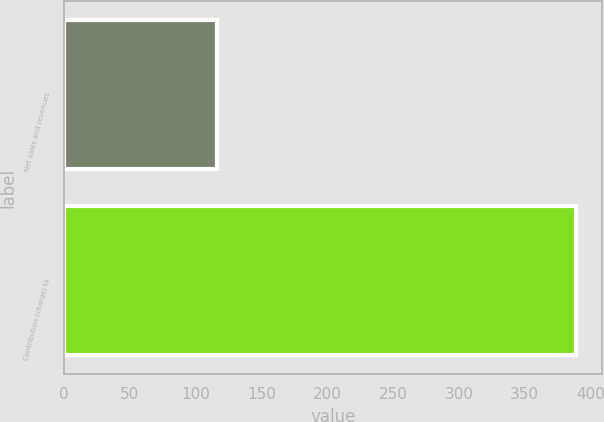Convert chart. <chart><loc_0><loc_0><loc_500><loc_500><bar_chart><fcel>Net sales and revenues<fcel>Contribution (charge) to<nl><fcel>116<fcel>389<nl></chart> 